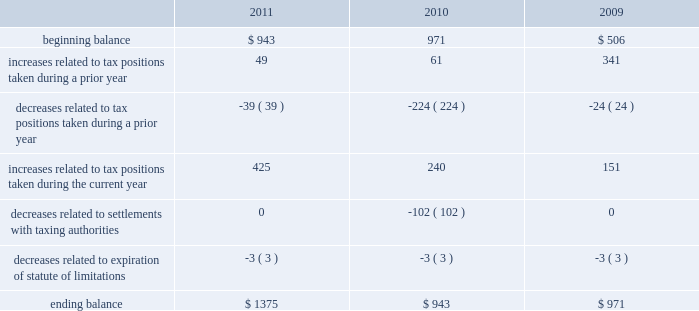As of september 24 , 2011 , the total amount of gross unrecognized tax benefits was $ 1.4 billion , of which $ 563 million , if recognized , would affect the company 2019s effective tax rate .
As of september 25 , 2010 , the total amount of gross unrecognized tax benefits was $ 943 million , of which $ 404 million , if recognized , would affect the company 2019s effective tax rate .
The aggregate changes in the balance of gross unrecognized tax benefits , which excludes interest and penalties , for the three years ended september 24 , 2011 , is as follows ( in millions ) : .
The company includes interest and penalties related to unrecognized tax benefits within the provision for income taxes .
As of september 24 , 2011 and september 25 , 2010 , the total amount of gross interest and penalties accrued was $ 261 million and $ 247 million , respectively , which is classified as non-current liabilities in the consolidated balance sheets .
In connection with tax matters , the company recognized interest expense in 2011 and 2009 of $ 14 million and $ 64 million , respectively , and in 2010 the company recognized an interest benefit of $ 43 million .
The company is subject to taxation and files income tax returns in the u.s .
Federal jurisdiction and in many state and foreign jurisdictions .
For u.s .
Federal income tax purposes , all years prior to 2004 are closed .
The internal revenue service ( the 201cirs 201d ) has completed its field audit of the company 2019s federal income tax returns for the years 2004 through 2006 and proposed certain adjustments .
The company has contested certain of these adjustments through the irs appeals office .
The irs is currently examining the years 2007 through 2009 .
In addition , the company is also subject to audits by state , local and foreign tax authorities .
In major states and major foreign jurisdictions , the years subsequent to 1988 and 2001 , respectively , generally remain open and could be subject to examination by the taxing authorities .
Management believes that an adequate provision has been made for any adjustments that may result from tax examinations .
However , the outcome of tax audits cannot be predicted with certainty .
If any issues addressed in the company 2019s tax audits are resolved in a manner not consistent with management 2019s expectations , the company could be required to adjust its provision for income tax in the period such resolution occurs .
Although timing of the resolution and/or closure of audits is not certain , the company does not believe it is reasonably possible that its unrecognized tax benefits would materially change in the next 12 months .
Note 6 2013 shareholders 2019 equity and share-based compensation preferred stock the company has five million shares of authorized preferred stock , none of which is issued or outstanding .
Under the terms of the company 2019s restated articles of incorporation , the board of directors is authorized to determine or alter the rights , preferences , privileges and restrictions of the company 2019s authorized but unissued shares of preferred stock .
Comprehensive income comprehensive income consists of two components , net income and other comprehensive income .
Other comprehensive income refers to revenue , expenses , gains and losses that under gaap are recorded as an element .
What was the net change in millions of the gross unrecognized tax benefits between 2010 and 2011? 
Computations: (1375 - 943)
Answer: 432.0. As of september 24 , 2011 , the total amount of gross unrecognized tax benefits was $ 1.4 billion , of which $ 563 million , if recognized , would affect the company 2019s effective tax rate .
As of september 25 , 2010 , the total amount of gross unrecognized tax benefits was $ 943 million , of which $ 404 million , if recognized , would affect the company 2019s effective tax rate .
The aggregate changes in the balance of gross unrecognized tax benefits , which excludes interest and penalties , for the three years ended september 24 , 2011 , is as follows ( in millions ) : .
The company includes interest and penalties related to unrecognized tax benefits within the provision for income taxes .
As of september 24 , 2011 and september 25 , 2010 , the total amount of gross interest and penalties accrued was $ 261 million and $ 247 million , respectively , which is classified as non-current liabilities in the consolidated balance sheets .
In connection with tax matters , the company recognized interest expense in 2011 and 2009 of $ 14 million and $ 64 million , respectively , and in 2010 the company recognized an interest benefit of $ 43 million .
The company is subject to taxation and files income tax returns in the u.s .
Federal jurisdiction and in many state and foreign jurisdictions .
For u.s .
Federal income tax purposes , all years prior to 2004 are closed .
The internal revenue service ( the 201cirs 201d ) has completed its field audit of the company 2019s federal income tax returns for the years 2004 through 2006 and proposed certain adjustments .
The company has contested certain of these adjustments through the irs appeals office .
The irs is currently examining the years 2007 through 2009 .
In addition , the company is also subject to audits by state , local and foreign tax authorities .
In major states and major foreign jurisdictions , the years subsequent to 1988 and 2001 , respectively , generally remain open and could be subject to examination by the taxing authorities .
Management believes that an adequate provision has been made for any adjustments that may result from tax examinations .
However , the outcome of tax audits cannot be predicted with certainty .
If any issues addressed in the company 2019s tax audits are resolved in a manner not consistent with management 2019s expectations , the company could be required to adjust its provision for income tax in the period such resolution occurs .
Although timing of the resolution and/or closure of audits is not certain , the company does not believe it is reasonably possible that its unrecognized tax benefits would materially change in the next 12 months .
Note 6 2013 shareholders 2019 equity and share-based compensation preferred stock the company has five million shares of authorized preferred stock , none of which is issued or outstanding .
Under the terms of the company 2019s restated articles of incorporation , the board of directors is authorized to determine or alter the rights , preferences , privileges and restrictions of the company 2019s authorized but unissued shares of preferred stock .
Comprehensive income comprehensive income consists of two components , net income and other comprehensive income .
Other comprehensive income refers to revenue , expenses , gains and losses that under gaap are recorded as an element .
How many years does the irs have under examination? 
Rationale: 2006 is the last closed year .
Computations: (2009 - 2006)
Answer: 3.0. As of september 24 , 2011 , the total amount of gross unrecognized tax benefits was $ 1.4 billion , of which $ 563 million , if recognized , would affect the company 2019s effective tax rate .
As of september 25 , 2010 , the total amount of gross unrecognized tax benefits was $ 943 million , of which $ 404 million , if recognized , would affect the company 2019s effective tax rate .
The aggregate changes in the balance of gross unrecognized tax benefits , which excludes interest and penalties , for the three years ended september 24 , 2011 , is as follows ( in millions ) : .
The company includes interest and penalties related to unrecognized tax benefits within the provision for income taxes .
As of september 24 , 2011 and september 25 , 2010 , the total amount of gross interest and penalties accrued was $ 261 million and $ 247 million , respectively , which is classified as non-current liabilities in the consolidated balance sheets .
In connection with tax matters , the company recognized interest expense in 2011 and 2009 of $ 14 million and $ 64 million , respectively , and in 2010 the company recognized an interest benefit of $ 43 million .
The company is subject to taxation and files income tax returns in the u.s .
Federal jurisdiction and in many state and foreign jurisdictions .
For u.s .
Federal income tax purposes , all years prior to 2004 are closed .
The internal revenue service ( the 201cirs 201d ) has completed its field audit of the company 2019s federal income tax returns for the years 2004 through 2006 and proposed certain adjustments .
The company has contested certain of these adjustments through the irs appeals office .
The irs is currently examining the years 2007 through 2009 .
In addition , the company is also subject to audits by state , local and foreign tax authorities .
In major states and major foreign jurisdictions , the years subsequent to 1988 and 2001 , respectively , generally remain open and could be subject to examination by the taxing authorities .
Management believes that an adequate provision has been made for any adjustments that may result from tax examinations .
However , the outcome of tax audits cannot be predicted with certainty .
If any issues addressed in the company 2019s tax audits are resolved in a manner not consistent with management 2019s expectations , the company could be required to adjust its provision for income tax in the period such resolution occurs .
Although timing of the resolution and/or closure of audits is not certain , the company does not believe it is reasonably possible that its unrecognized tax benefits would materially change in the next 12 months .
Note 6 2013 shareholders 2019 equity and share-based compensation preferred stock the company has five million shares of authorized preferred stock , none of which is issued or outstanding .
Under the terms of the company 2019s restated articles of incorporation , the board of directors is authorized to determine or alter the rights , preferences , privileges and restrictions of the company 2019s authorized but unissued shares of preferred stock .
Comprehensive income comprehensive income consists of two components , net income and other comprehensive income .
Other comprehensive income refers to revenue , expenses , gains and losses that under gaap are recorded as an element .
What was the increase in interest expense between 2009 and 2011? 
Computations: (64 - 14)
Answer: 50.0. 